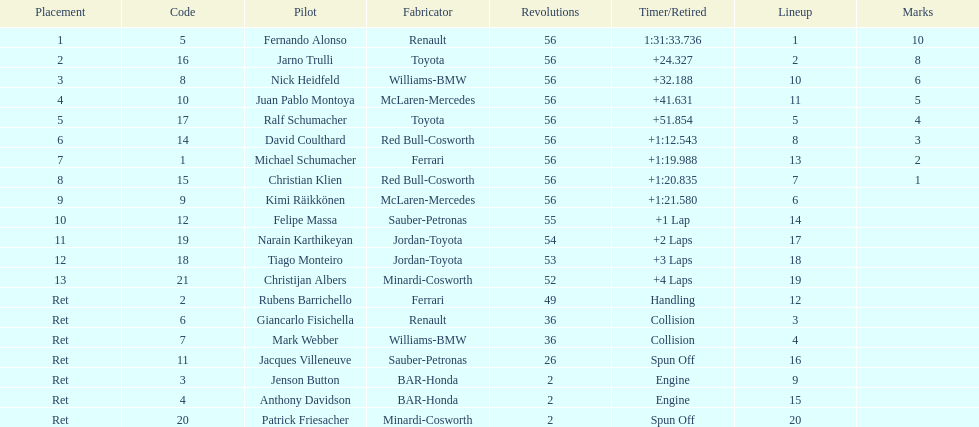How many drivers were retired before the race could end? 7. 